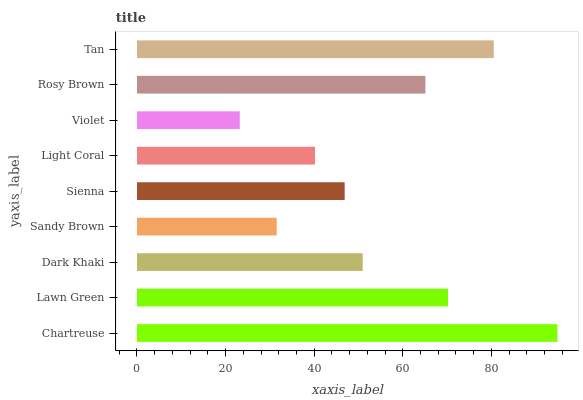Is Violet the minimum?
Answer yes or no. Yes. Is Chartreuse the maximum?
Answer yes or no. Yes. Is Lawn Green the minimum?
Answer yes or no. No. Is Lawn Green the maximum?
Answer yes or no. No. Is Chartreuse greater than Lawn Green?
Answer yes or no. Yes. Is Lawn Green less than Chartreuse?
Answer yes or no. Yes. Is Lawn Green greater than Chartreuse?
Answer yes or no. No. Is Chartreuse less than Lawn Green?
Answer yes or no. No. Is Dark Khaki the high median?
Answer yes or no. Yes. Is Dark Khaki the low median?
Answer yes or no. Yes. Is Tan the high median?
Answer yes or no. No. Is Chartreuse the low median?
Answer yes or no. No. 